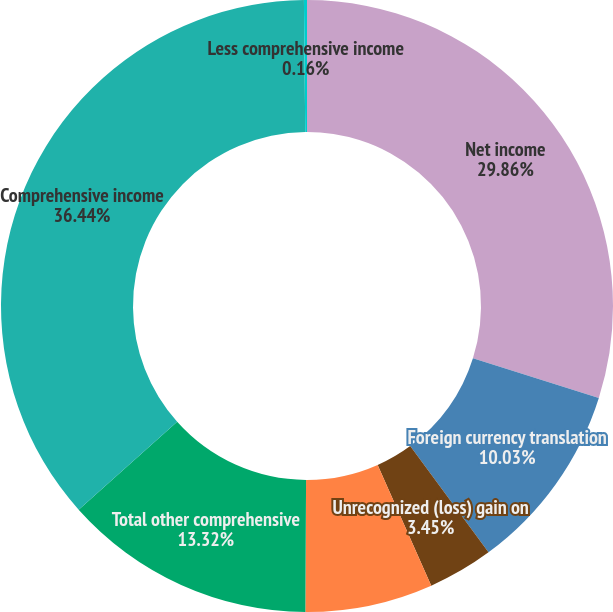Convert chart. <chart><loc_0><loc_0><loc_500><loc_500><pie_chart><fcel>Net income<fcel>Foreign currency translation<fcel>Unrecognized (loss) gain on<fcel>Pension adjustments<fcel>Total other comprehensive<fcel>Comprehensive income<fcel>Less comprehensive income<nl><fcel>29.86%<fcel>10.03%<fcel>3.45%<fcel>6.74%<fcel>13.32%<fcel>36.43%<fcel>0.16%<nl></chart> 